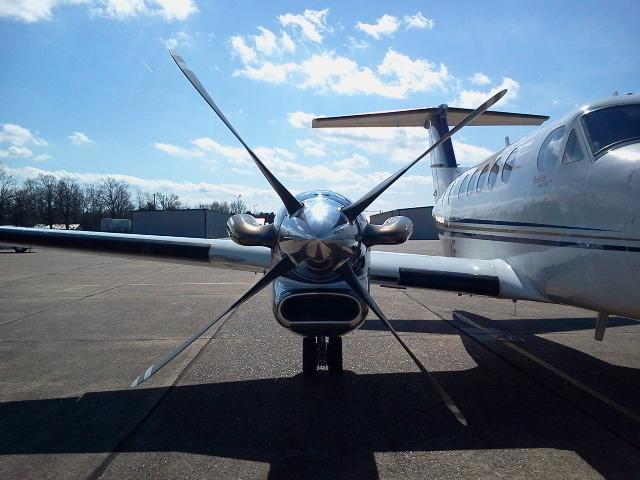How many airplanes are in the picture?
Give a very brief answer. 1. 